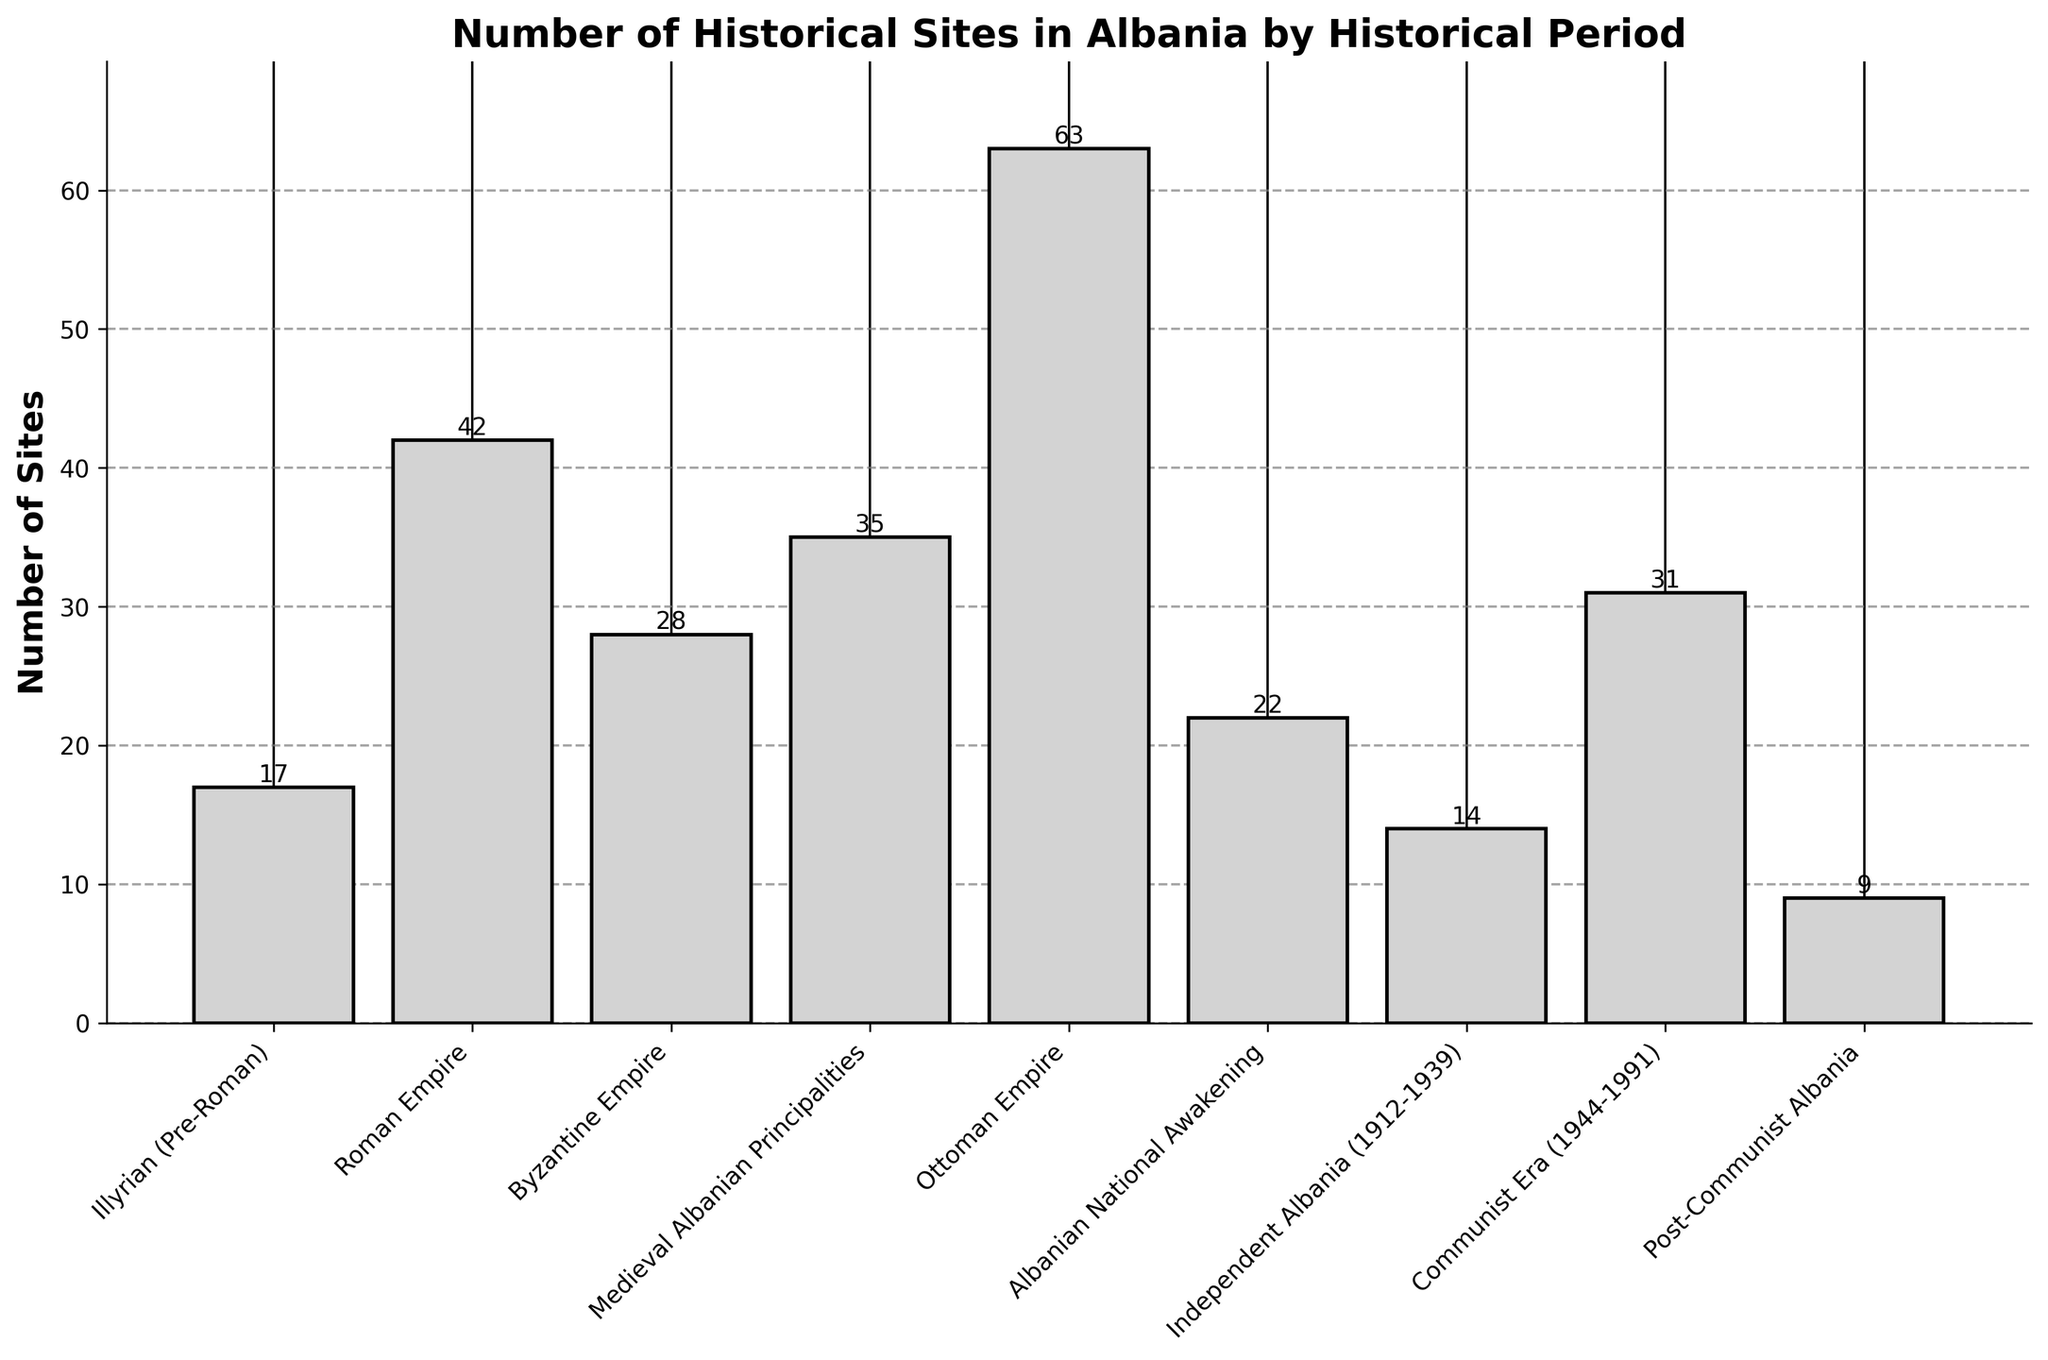How many historical periods are represented in the chart? Count the number of distinct historical periods listed along the x-axis. There are 9 periods from "Illyrian (Pre-Roman)" to "Post-Communist Albania".
Answer: 9 Which historical period has the most number of sites? Identify the tallest bar in the chart. The "Ottoman Empire" bar is the tallest, indicating it has the most sites.
Answer: Ottoman Empire What is the total number of historical sites represented in the chart? Sum the number of sites for all historical periods: 17 + 42 + 28 + 35 + 63 + 22 + 14 + 31 + 9. The total is 261.
Answer: 261 Which periods have fewer than 20 sites? Look for bars that reach a height below 20. The periods are "Illyrian (Pre-Roman)" with 17 sites, "Independent Albania (1912-1939)" with 14 sites, and "Post-Communist Albania" with 9 sites.
Answer: Illyrian (Pre-Roman), Independent Albania (1912-1939), Post-Communist Albania What is the difference in the number of sites between the Ottoman Empire and the Roman Empire periods? Subtract the number of sites in the Roman Empire period (42) from the number of sites in the Ottoman Empire period (63). The difference is 63 - 42 = 21.
Answer: 21 Which period experienced a growth in the number of sites compared to its preceding period? Compare the heights of each pair of adjacent bars. The Medieval Albanian Principalities (35 sites) has more sites than the Byzantine Empire (28 sites), showing growth. Similarly, the Communist Era (31 sites) has more sites than Independent Albania (14 sites).
Answer: Medieval Albanian Principalities, Communist Era What is the average number of historical sites per period? Calculate the total number of sites (261) and divide it by the number of periods (9). The average is 261 ÷ 9 = 29.
Answer: 29 Which two periods have the closest number of sites? Compare the heights of bars visually to find the two closest. The Byzantine Empire (28 sites) and the Albanian National Awakening (22 sites) are the closest with a difference of 6.
Answer: Byzantine Empire, Albanian National Awakening How many more sites are in the Ottoman Empire period compared to the Illyrian (Pre-Roman) period? Subtract the number of sites in the Illyrian (Pre-Roman) period (17) from the number of sites in the Ottoman Empire period (63). The difference is 63 - 17 = 46.
Answer: 46 What is the median number of sites across all periods? List the number of sites in ascending order: 9, 14, 17, 22, 28, 31, 35, 42, 63. The median is the middle value, which is 28.
Answer: 28 